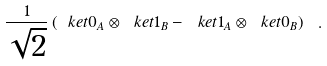<formula> <loc_0><loc_0><loc_500><loc_500>\frac { 1 } { \sqrt { 2 } } \left ( \ k e t { 0 } _ { A } \otimes \ k e t { 1 } _ { B } - \ k e t { 1 } _ { A } \otimes \ k e t { 0 } _ { B } \right ) \ .</formula> 